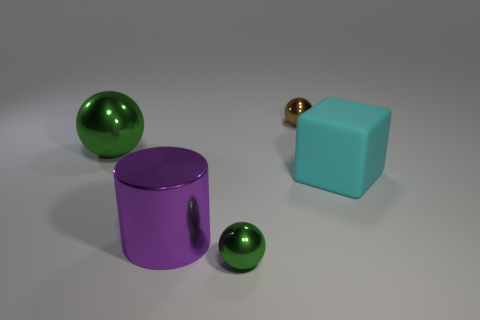What number of small gray metallic objects are there?
Keep it short and to the point. 0. How many shiny things are on the left side of the purple cylinder and behind the large green metallic ball?
Give a very brief answer. 0. Is there any other thing that is the same shape as the large cyan thing?
Keep it short and to the point. No. Do the big metal ball and the shiny sphere in front of the cyan block have the same color?
Provide a succinct answer. Yes. The green thing in front of the purple metal thing has what shape?
Give a very brief answer. Sphere. What number of other objects are there of the same material as the big purple object?
Your response must be concise. 3. What is the material of the cyan cube?
Ensure brevity in your answer.  Rubber. What number of big things are cyan rubber objects or yellow cubes?
Give a very brief answer. 1. There is a tiny brown metallic sphere; how many big cylinders are in front of it?
Keep it short and to the point. 1. Are there any large cubes that have the same color as the big sphere?
Offer a very short reply. No. 